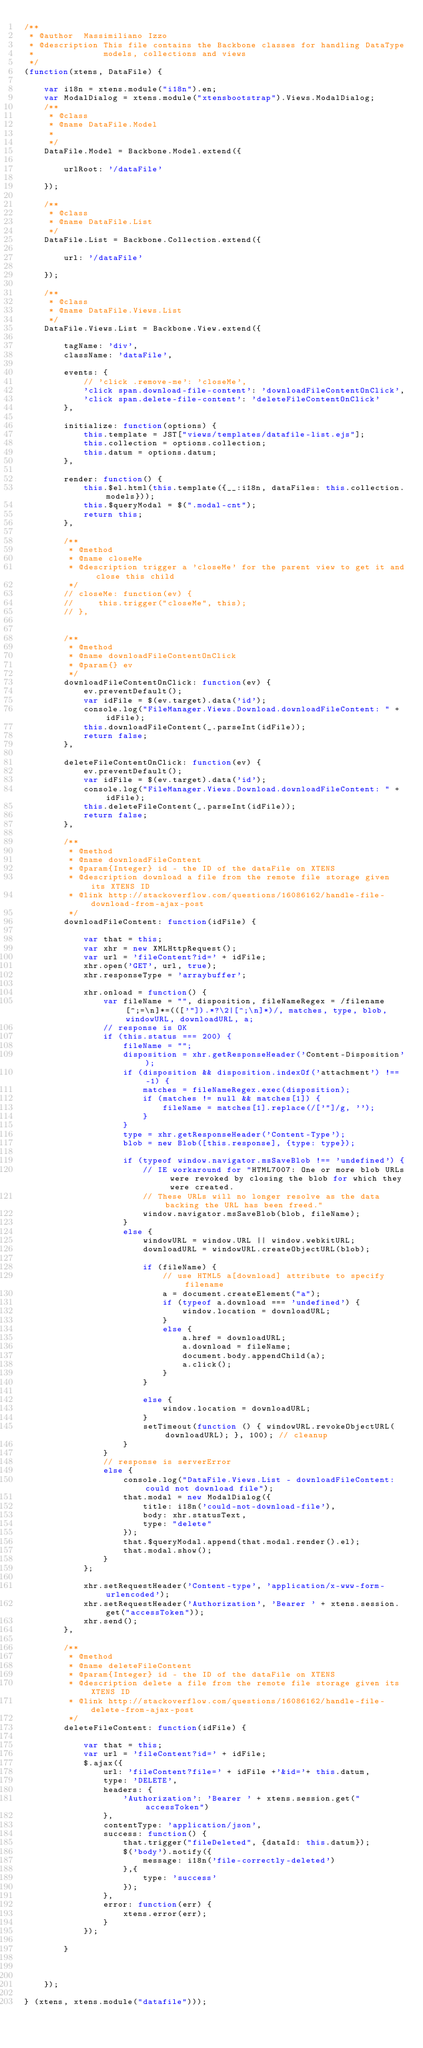<code> <loc_0><loc_0><loc_500><loc_500><_JavaScript_>/**
 * @author  Massimiliano Izzo
 * @description This file contains the Backbone classes for handling DataType
 *              models, collections and views
 */
(function(xtens, DataFile) {

    var i18n = xtens.module("i18n").en;
    var ModalDialog = xtens.module("xtensbootstrap").Views.ModalDialog;
    /**
     * @class
     * @name DataFile.Model
     *
     */
    DataFile.Model = Backbone.Model.extend({

        urlRoot: '/dataFile'

    });

    /**
     * @class
     * @name DataFile.List
     */
    DataFile.List = Backbone.Collection.extend({

        url: '/dataFile'

    });

    /**
     * @class
     * @name DataFile.Views.List
     */
    DataFile.Views.List = Backbone.View.extend({

        tagName: 'div',
        className: 'dataFile',

        events: {
            // 'click .remove-me': 'closeMe',
            'click span.download-file-content': 'downloadFileContentOnClick',
            'click span.delete-file-content': 'deleteFileContentOnClick'
        },

        initialize: function(options) {
            this.template = JST["views/templates/datafile-list.ejs"];
            this.collection = options.collection;
            this.datum = options.datum;
        },

        render: function() {
            this.$el.html(this.template({__:i18n, dataFiles: this.collection.models}));
            this.$queryModal = $(".modal-cnt");
            return this;
        },

        /**
         * @method
         * @name closeMe
         * @description trigger a 'closeMe' for the parent view to get it and close this child
         */
        // closeMe: function(ev) {
        //     this.trigger("closeMe", this);
        // },


        /**
         * @method
         * @name downloadFileContentOnClick
         * @param{} ev
         */
        downloadFileContentOnClick: function(ev) {
            ev.preventDefault();
            var idFile = $(ev.target).data('id');
            console.log("FileManager.Views.Download.downloadFileContent: " + idFile);
            this.downloadFileContent(_.parseInt(idFile));
            return false;
        },

        deleteFileContentOnClick: function(ev) {
            ev.preventDefault();
            var idFile = $(ev.target).data('id');
            console.log("FileManager.Views.Download.downloadFileContent: " + idFile);
            this.deleteFileContent(_.parseInt(idFile));
            return false;
        },

        /**
         * @method
         * @name downloadFileContent
         * @param{Integer} id - the ID of the dataFile on XTENS
         * @description download a file from the remote file storage given its XTENS ID
         * @link http://stackoverflow.com/questions/16086162/handle-file-download-from-ajax-post
         */
        downloadFileContent: function(idFile) {

            var that = this;
            var xhr = new XMLHttpRequest();
            var url = 'fileContent?id=' + idFile;
            xhr.open('GET', url, true);
            xhr.responseType = 'arraybuffer';

            xhr.onload = function() {
                var fileName = "", disposition, fileNameRegex = /filename[^;=\n]*=((['"]).*?\2|[^;\n]*)/, matches, type, blob, windowURL, downloadURL, a;
                // response is OK
                if (this.status === 200) {
                    fileName = "";
                    disposition = xhr.getResponseHeader('Content-Disposition');
                    if (disposition && disposition.indexOf('attachment') !== -1) {
                        matches = fileNameRegex.exec(disposition);
                        if (matches != null && matches[1]) {
                            fileName = matches[1].replace(/['"]/g, '');
                        }
                    }
                    type = xhr.getResponseHeader('Content-Type');
                    blob = new Blob([this.response], {type: type});

                    if (typeof window.navigator.msSaveBlob !== 'undefined') {
                        // IE workaround for "HTML7007: One or more blob URLs were revoked by closing the blob for which they were created.
                        // These URLs will no longer resolve as the data backing the URL has been freed."
                        window.navigator.msSaveBlob(blob, fileName);
                    }
                    else {
                        windowURL = window.URL || window.webkitURL;
                        downloadURL = windowURL.createObjectURL(blob);

                        if (fileName) {
                            // use HTML5 a[download] attribute to specify filename
                            a = document.createElement("a");
                            if (typeof a.download === 'undefined') {
                                window.location = downloadURL;
                            }
                            else {
                                a.href = downloadURL;
                                a.download = fileName;
                                document.body.appendChild(a);
                                a.click();
                            }
                        }

                        else {
                            window.location = downloadURL;
                        }
                        setTimeout(function () { windowURL.revokeObjectURL(downloadURL); }, 100); // cleanup
                    }
                }
                // response is serverError
                else {
                    console.log("DataFile.Views.List - downloadFileContent: could not download file");
                    that.modal = new ModalDialog({
                        title: i18n('could-not-download-file'),
                        body: xhr.statusText,
                        type: "delete"
                    });
                    that.$queryModal.append(that.modal.render().el);
                    that.modal.show();
                }
            };

            xhr.setRequestHeader('Content-type', 'application/x-www-form-urlencoded');
            xhr.setRequestHeader('Authorization', 'Bearer ' + xtens.session.get("accessToken"));
            xhr.send();
        },

        /**
         * @method
         * @name deleteFileContent
         * @param{Integer} id - the ID of the dataFile on XTENS
         * @description delete a file from the remote file storage given its XTENS ID
         * @link http://stackoverflow.com/questions/16086162/handle-file-delete-from-ajax-post
         */
        deleteFileContent: function(idFile) {

            var that = this;
            var url = 'fileContent?id=' + idFile;
            $.ajax({
                url: 'fileContent?file=' + idFile +'&id='+ this.datum,
                type: 'DELETE',
                headers: {
                    'Authorization': 'Bearer ' + xtens.session.get("accessToken")
                },
                contentType: 'application/json',
                success: function() {
                    that.trigger("fileDeleted", {dataId: this.datum});
                    $('body').notify({
                        message: i18n('file-correctly-deleted')
                    },{
                        type: 'success'
                    });
                },
                error: function(err) {
                    xtens.error(err);
                }
            });

        }



    });

} (xtens, xtens.module("datafile")));
</code> 